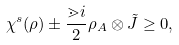<formula> <loc_0><loc_0><loc_500><loc_500>\chi ^ { s } ( \rho ) \pm \frac { \mathbb { m } { i } } { 2 } \rho _ { A } \otimes \tilde { J } \geq 0 ,</formula> 